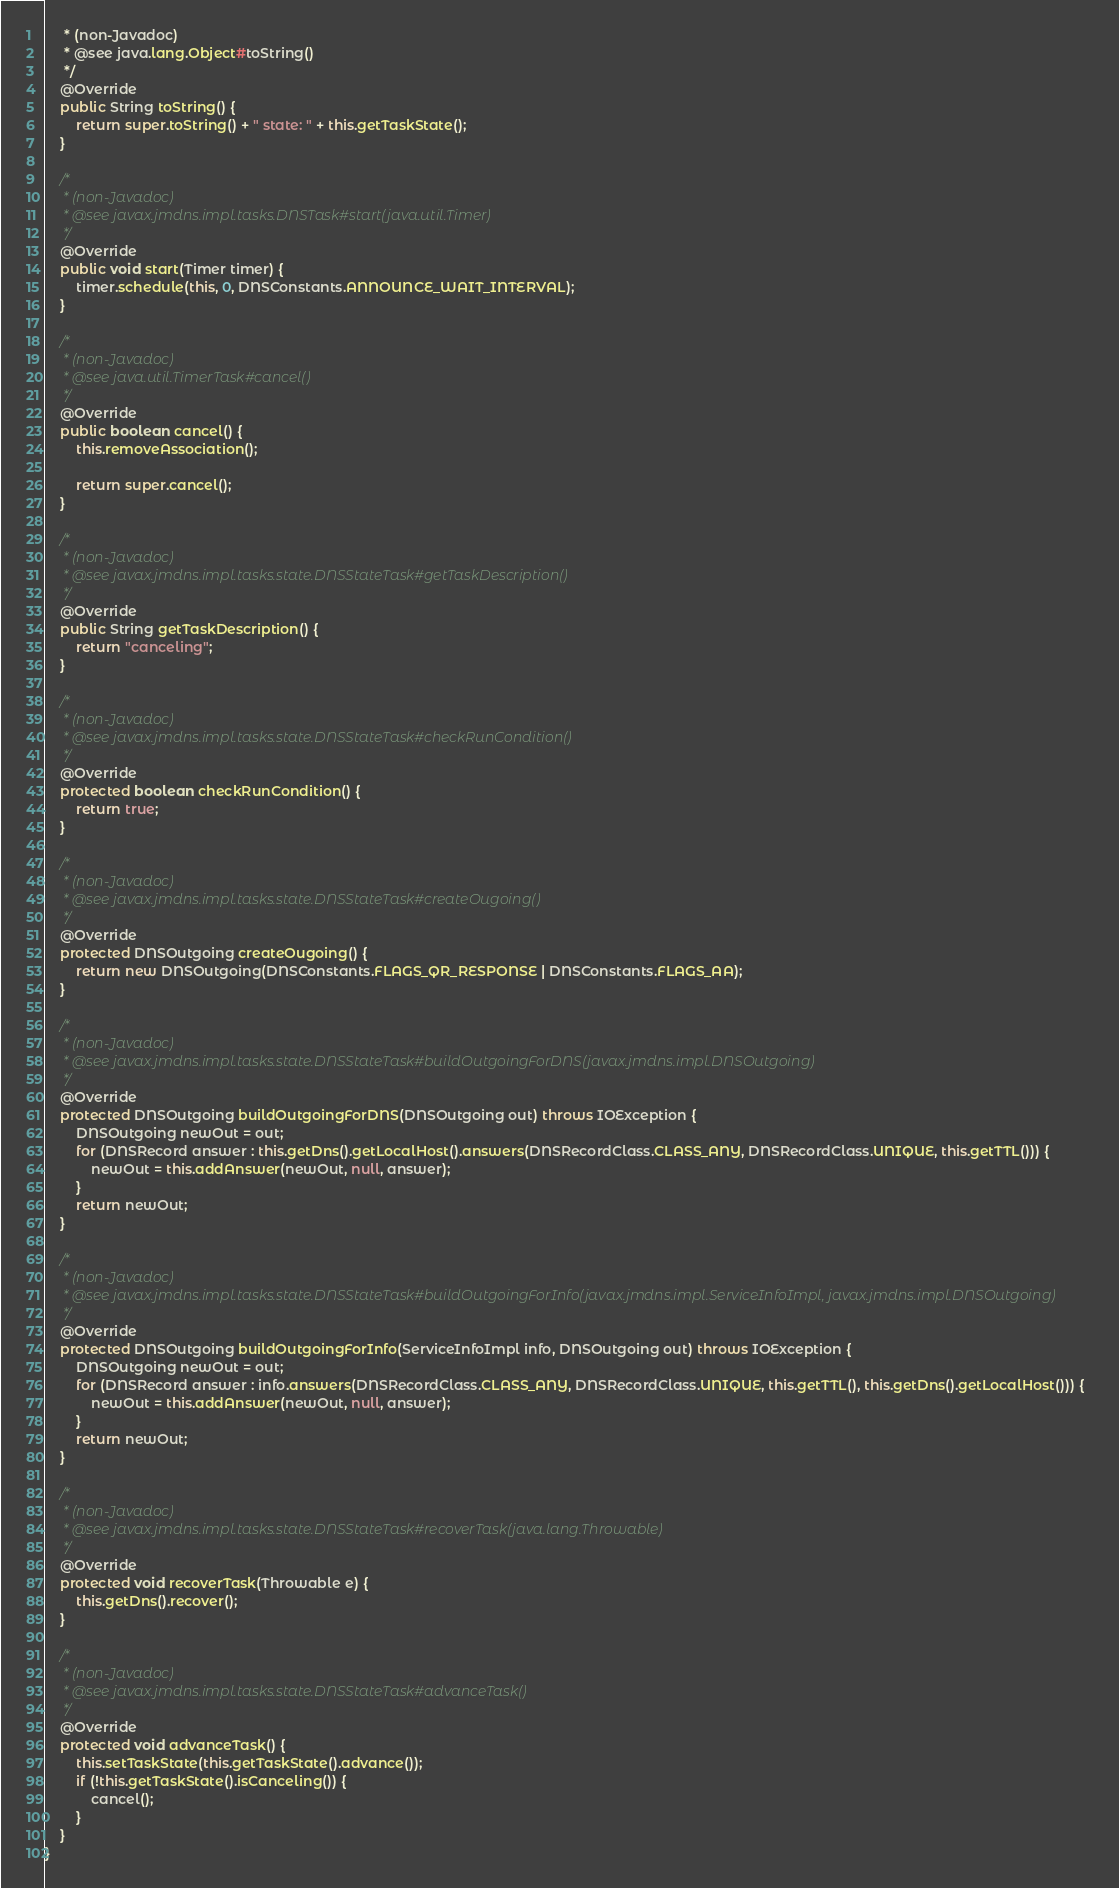<code> <loc_0><loc_0><loc_500><loc_500><_Java_>     * (non-Javadoc)
     * @see java.lang.Object#toString()
     */
    @Override
    public String toString() {
        return super.toString() + " state: " + this.getTaskState();
    }

    /*
     * (non-Javadoc)
     * @see javax.jmdns.impl.tasks.DNSTask#start(java.util.Timer)
     */
    @Override
    public void start(Timer timer) {
        timer.schedule(this, 0, DNSConstants.ANNOUNCE_WAIT_INTERVAL);
    }

    /*
     * (non-Javadoc)
     * @see java.util.TimerTask#cancel()
     */
    @Override
    public boolean cancel() {
        this.removeAssociation();

        return super.cancel();
    }

    /*
     * (non-Javadoc)
     * @see javax.jmdns.impl.tasks.state.DNSStateTask#getTaskDescription()
     */
    @Override
    public String getTaskDescription() {
        return "canceling";
    }

    /*
     * (non-Javadoc)
     * @see javax.jmdns.impl.tasks.state.DNSStateTask#checkRunCondition()
     */
    @Override
    protected boolean checkRunCondition() {
        return true;
    }

    /*
     * (non-Javadoc)
     * @see javax.jmdns.impl.tasks.state.DNSStateTask#createOugoing()
     */
    @Override
    protected DNSOutgoing createOugoing() {
        return new DNSOutgoing(DNSConstants.FLAGS_QR_RESPONSE | DNSConstants.FLAGS_AA);
    }

    /*
     * (non-Javadoc)
     * @see javax.jmdns.impl.tasks.state.DNSStateTask#buildOutgoingForDNS(javax.jmdns.impl.DNSOutgoing)
     */
    @Override
    protected DNSOutgoing buildOutgoingForDNS(DNSOutgoing out) throws IOException {
        DNSOutgoing newOut = out;
        for (DNSRecord answer : this.getDns().getLocalHost().answers(DNSRecordClass.CLASS_ANY, DNSRecordClass.UNIQUE, this.getTTL())) {
            newOut = this.addAnswer(newOut, null, answer);
        }
        return newOut;
    }

    /*
     * (non-Javadoc)
     * @see javax.jmdns.impl.tasks.state.DNSStateTask#buildOutgoingForInfo(javax.jmdns.impl.ServiceInfoImpl, javax.jmdns.impl.DNSOutgoing)
     */
    @Override
    protected DNSOutgoing buildOutgoingForInfo(ServiceInfoImpl info, DNSOutgoing out) throws IOException {
        DNSOutgoing newOut = out;
        for (DNSRecord answer : info.answers(DNSRecordClass.CLASS_ANY, DNSRecordClass.UNIQUE, this.getTTL(), this.getDns().getLocalHost())) {
            newOut = this.addAnswer(newOut, null, answer);
        }
        return newOut;
    }

    /*
     * (non-Javadoc)
     * @see javax.jmdns.impl.tasks.state.DNSStateTask#recoverTask(java.lang.Throwable)
     */
    @Override
    protected void recoverTask(Throwable e) {
        this.getDns().recover();
    }

    /*
     * (non-Javadoc)
     * @see javax.jmdns.impl.tasks.state.DNSStateTask#advanceTask()
     */
    @Override
    protected void advanceTask() {
        this.setTaskState(this.getTaskState().advance());
        if (!this.getTaskState().isCanceling()) {
            cancel();
        }
    }
}</code> 